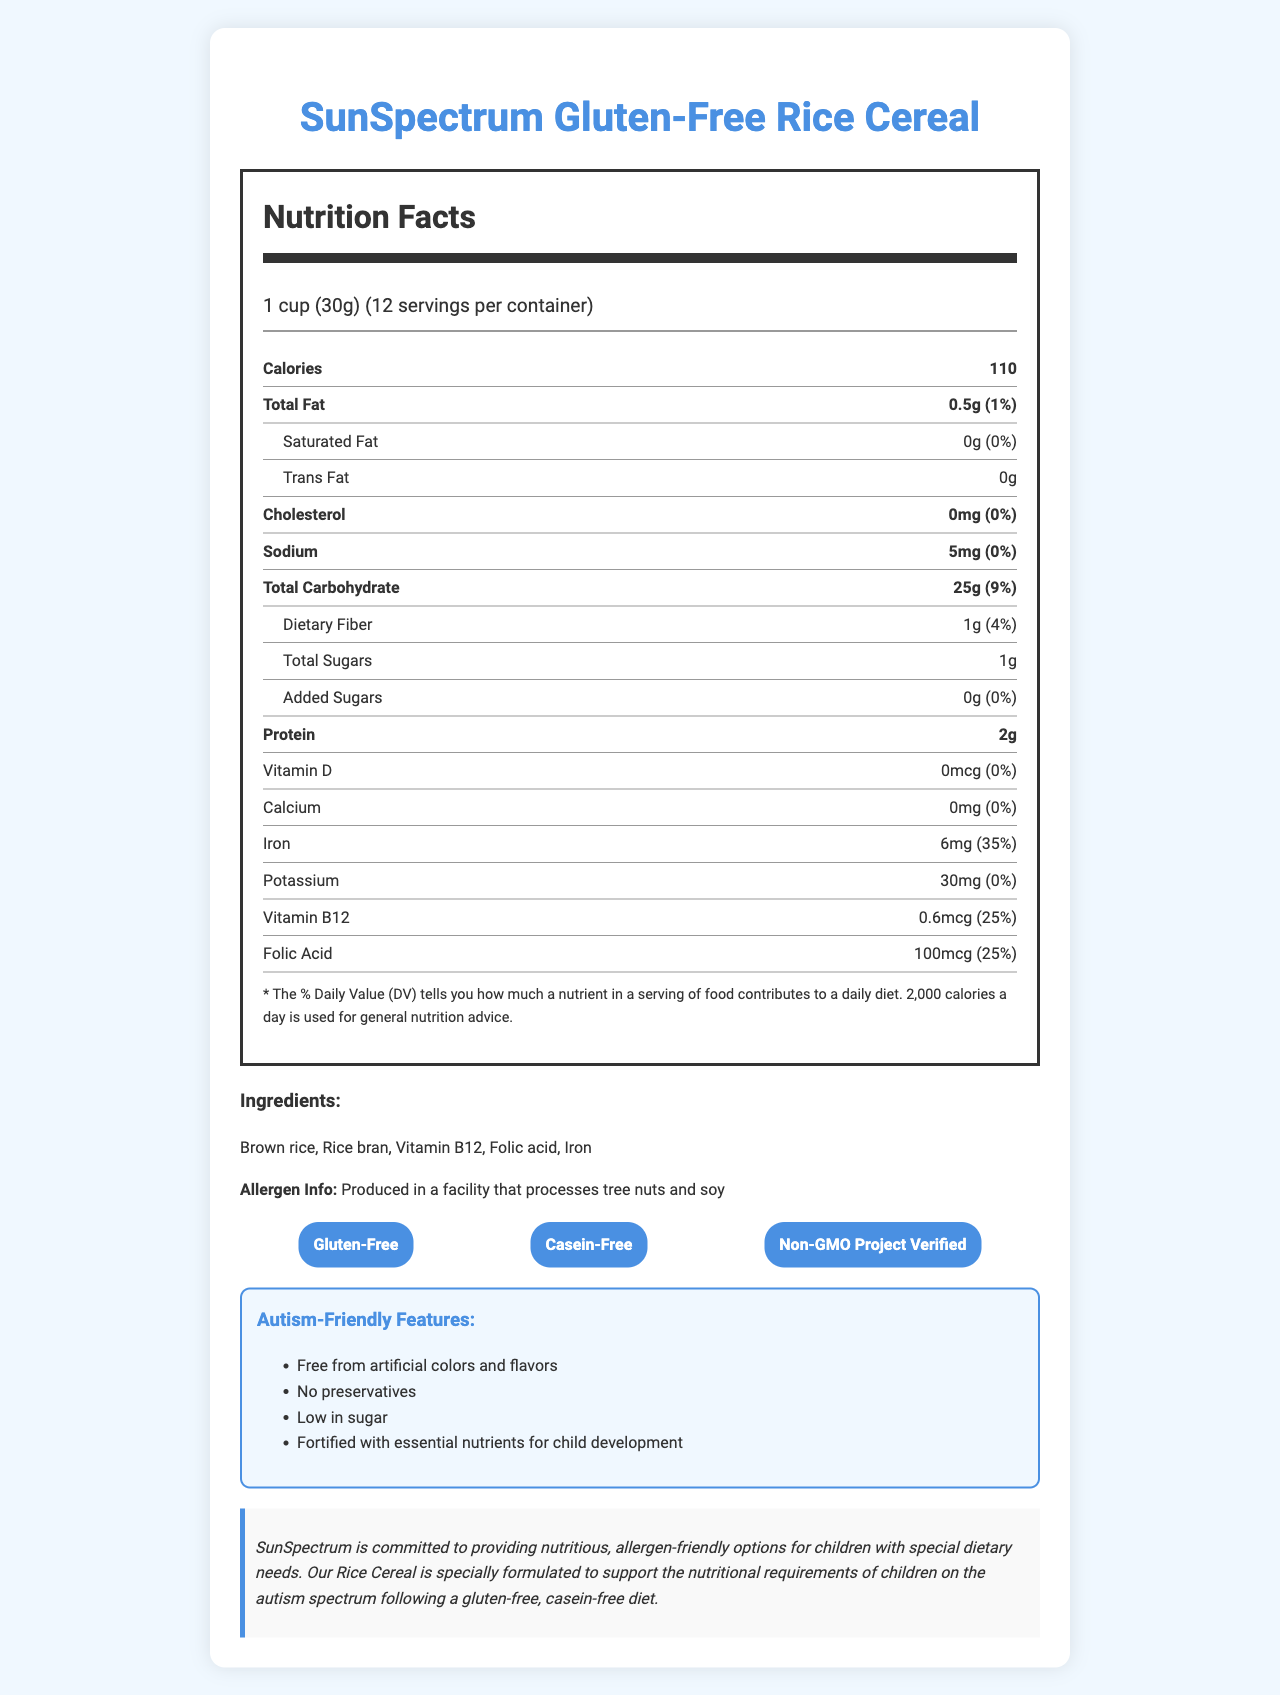what is the serving size of the rice cereal? The serving size is clearly stated in the nutrition facts under the "serving size" section.
Answer: 1 cup (30g) how many servings are in one container? The number of servings per container is listed under the "servings per container" section.
Answer: 12 how many calories are there per serving? The calories per serving are listed directly below the serving size information.
Answer: 110 what is the total fat content per serving? The total fat content per serving is listed under the "Total Fat" category.
Answer: 0.5g what nutrients are fortified in the rice cereal? The nutrients that are fortified are mentioned under the "autism-friendly features" and in the ingredients list.
Answer: Iron, Vitamin B12, Folic Acid which of the following certifications does this product have? A. Organic B. Non-GMO Project Verified C. Vegan D. Certified Kosher The product is "Non-GMO Project Verified," as listed in the dietary certifications section.
Answer: B how much sodium is in each serving? A. 0mg B. 5mg C. 10mg D. 15mg The sodium content per serving is listed as 5mg under the "Sodium" category.
Answer: B is the product suitable for children with gluten sensitivity? The product is labeled as gluten-free, making it suitable for children with gluten sensitivity.
Answer: Yes does the product contain any artificial colors or flavors? The "autism-friendly features" section specifies that the product is free from artificial colors and flavors.
Answer: No summarize the main idea of the document. The document covers the nutritional facts, allergen information, dietary certifications, and autism-friendly features, emphasizing the product’s compliance with special dietary needs.
Answer: The document provides detailed nutritional information about SunSpectrum Gluten-Free Rice Cereal, highlighting its suitability for children on a gluten-free, casein-free diet. It includes the nutritional content, ingredients, dietary certifications, and features that make it autism-friendly. what is the carbohydrate content per serving? The total carbohydrate content per serving is listed under the "Total Carbohydrate" section.
Answer: 25g what is the protein content per serving? The protein content per serving is listed toward the bottom of the nutrition facts section.
Answer: 2g how much iron is in one serving, and what percentage of the daily value does it contribute? The document states that one serving contains 6mg of iron, contributing 35% of the daily value.
Answer: 6mg, 35% what is the amount of added sugars in this product? The amount of added sugars is listed as 0g under the "Added Sugars" section.
Answer: 0g what dietary fiber content does the product have? The dietary fiber content per serving is listed under the "Dietary Fiber" section.
Answer: 1g does the product contain any preservatives? A. Yes B. No Under the autism-friendly features, it states that the product has no preservatives.
Answer: B how much vitamin D does each serving provide? The vitamin D content per serving is listed under the "Vitamin D" section.
Answer: 0mcg does the document provide information about the product's manufacturing process? The document does not include detailed information about the manufacturing process, only that it is produced in a facility that processes tree nuts and soy.
Answer: Not enough information 